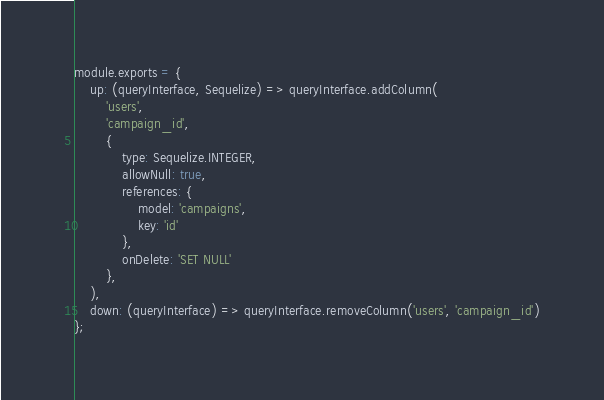<code> <loc_0><loc_0><loc_500><loc_500><_JavaScript_>module.exports = {
    up: (queryInterface, Sequelize) => queryInterface.addColumn(
        'users',
        'campaign_id',
        {
            type: Sequelize.INTEGER,
            allowNull: true,
            references: {
                model: 'campaigns',
                key: 'id'
            },
            onDelete: 'SET NULL'
        },
    ),
    down: (queryInterface) => queryInterface.removeColumn('users', 'campaign_id')
};
</code> 